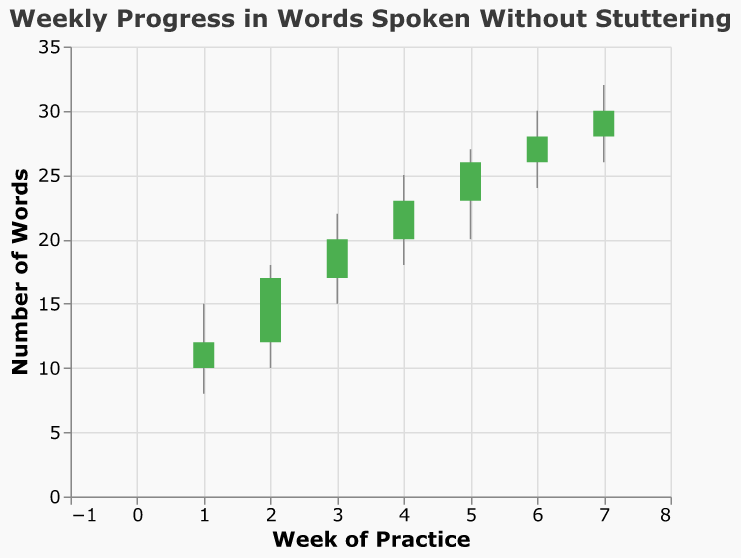What's the title of the figure? The title of the figure is "Weekly Progress in Words Spoken Without Stuttering." This is clearly shown at the top of the figure.
Answer: Weekly Progress in Words Spoken Without Stuttering What is the highest number of words spoken without stuttering in Week 5? To find the highest number of words spoken without stuttering in Week 5, we look at the "High" value for Week 5. The High value for Week 5 is 27.
Answer: 27 In which week did the number of words spoken without stuttering increase the most, and by how much? To find the week with the highest increase, we calculate the difference between the closing number of words from one week and the previous week. 
- Week 1 to 2: 17 - 12 = 5
- Week 2 to 3: 20 - 17 = 3
- Week 3 to 4: 23 - 20 = 3
- Week 4 to 5: 26 - 23 = 3
- Week 5 to 6: 28 - 26 = 2
- Week 6 to 7: 30 - 28 = 2
Week 1 to 2 has the highest increase, which is 5.
Answer: Week 2, 5 Which week had the smallest range of words spoken without stuttering? To find the week with the smallest range, we subtract the Low value from the High value for each week:
- Week 1: 15 - 8 = 7
- Week 2: 18 - 10 = 8
- Week 3: 22 - 15 = 7
- Week 4: 25 - 18 = 7
- Week 5: 27 - 20 = 7
- Week 6: 30 - 24 = 6
- Week 7: 32 - 26 = 6
Both Weeks 6 and 7 have the smallest range, which is 6.
Answer: Week 6, 6 Was there any week where the number of words spoken without stuttering decreased? To check if there was any decrease, we compare the Open and Close values for each week. If the Open value is greater than the Close value, it indicates a decrease. All weeks show an increase since Open is always less than Close.
Answer: No In which week did the words spoken without stuttering reach a low of 24 words? The low value of 24 words is reached in Week 6. This is found by looking at the Low value for each week.
Answer: Week 6 What was the average number of words spoken without stuttering at the close of each week? To find the average, we sum up the Close values and divide by the number of weeks:
(12 + 17 + 20 + 23 + 26 + 28 + 30) / 7 = 156 / 7 = 22.29
Answer: 22.29 Between which weeks was the number of words spoken without stuttering highest at the end of the week? To find the highest number of words spoken without stuttering at the end of the week, we compare the Close values:
Week 7 has the highest Close value at 30.
Answer: Week 7 